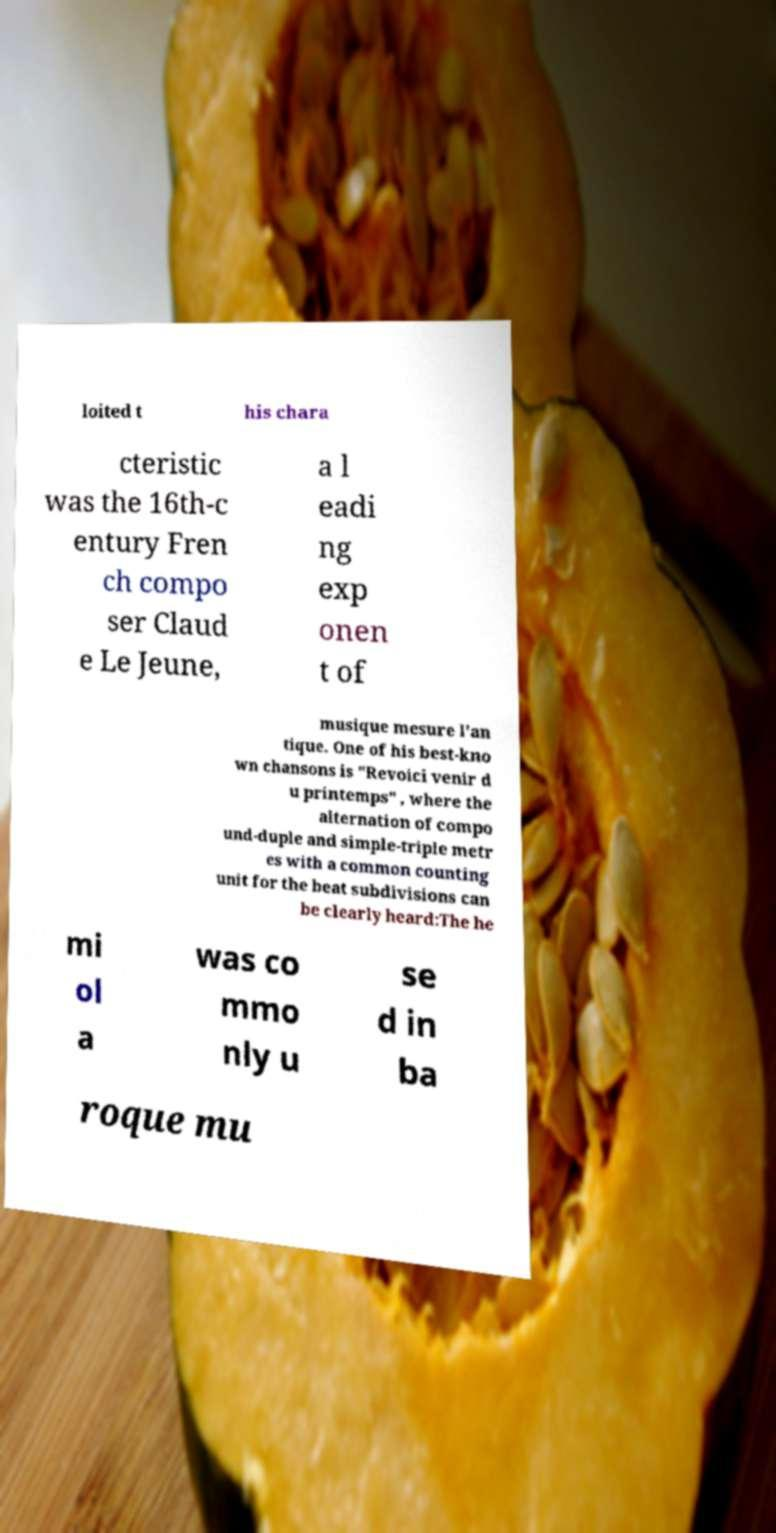Please read and relay the text visible in this image. What does it say? loited t his chara cteristic was the 16th-c entury Fren ch compo ser Claud e Le Jeune, a l eadi ng exp onen t of musique mesure l'an tique. One of his best-kno wn chansons is "Revoici venir d u printemps" , where the alternation of compo und-duple and simple-triple metr es with a common counting unit for the beat subdivisions can be clearly heard:The he mi ol a was co mmo nly u se d in ba roque mu 